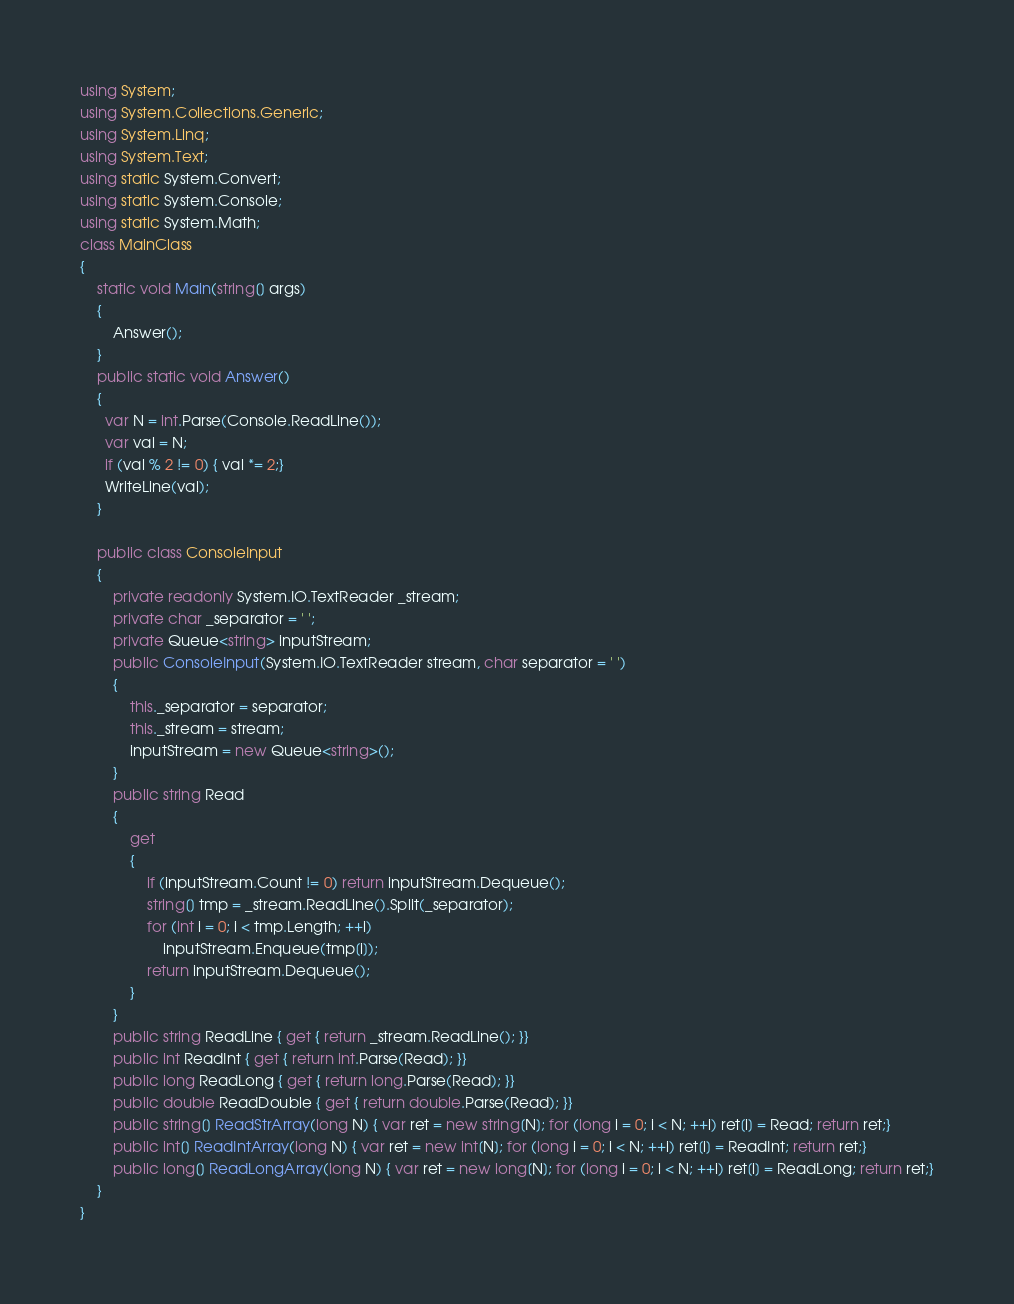<code> <loc_0><loc_0><loc_500><loc_500><_C#_>using System;
using System.Collections.Generic;
using System.Linq;
using System.Text;
using static System.Convert;
using static System.Console;
using static System.Math;
class MainClass
{
	static void Main(string[] args)
	{
		Answer();
	}
	public static void Answer()
	{
	  var N = int.Parse(Console.ReadLine());
      var val = N;
      if (val % 2 != 0) { val *= 2;}
      WriteLine(val);
	}
  
    public class ConsoleInput
    {
        private readonly System.IO.TextReader _stream;
        private char _separator = ' ';
        private Queue<string> inputStream;
        public ConsoleInput(System.IO.TextReader stream, char separator = ' ')
        {
            this._separator = separator;
            this._stream = stream;
            inputStream = new Queue<string>();
        }
        public string Read
        {
            get
            {
                if (inputStream.Count != 0) return inputStream.Dequeue();
                string[] tmp = _stream.ReadLine().Split(_separator);
                for (int i = 0; i < tmp.Length; ++i)
                    inputStream.Enqueue(tmp[i]);
                return inputStream.Dequeue();
            }
        }
        public string ReadLine { get { return _stream.ReadLine(); }}
        public int ReadInt { get { return int.Parse(Read); }}
        public long ReadLong { get { return long.Parse(Read); }}
        public double ReadDouble { get { return double.Parse(Read); }}
        public string[] ReadStrArray(long N) { var ret = new string[N]; for (long i = 0; i < N; ++i) ret[i] = Read; return ret;}
        public int[] ReadIntArray(long N) { var ret = new int[N]; for (long i = 0; i < N; ++i) ret[i] = ReadInt; return ret;}
        public long[] ReadLongArray(long N) { var ret = new long[N]; for (long i = 0; i < N; ++i) ret[i] = ReadLong; return ret;}
    }
}</code> 